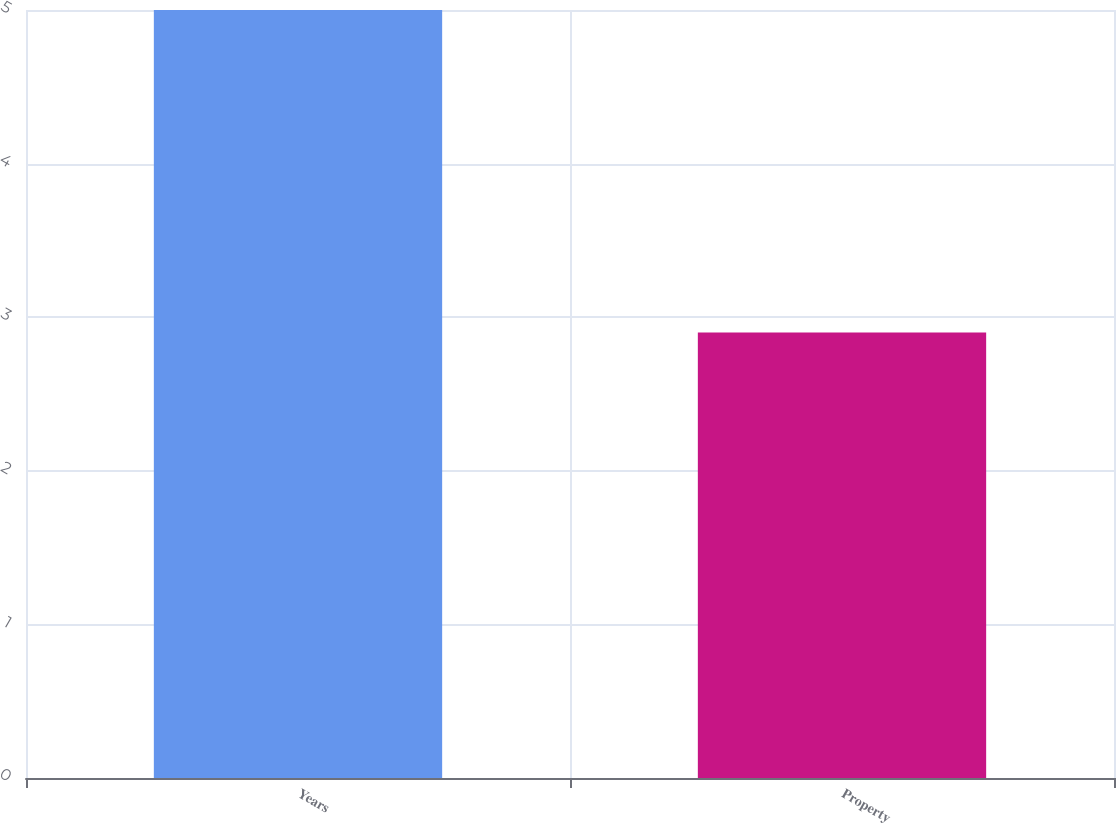Convert chart. <chart><loc_0><loc_0><loc_500><loc_500><bar_chart><fcel>Years<fcel>Property<nl><fcel>5<fcel>2.9<nl></chart> 